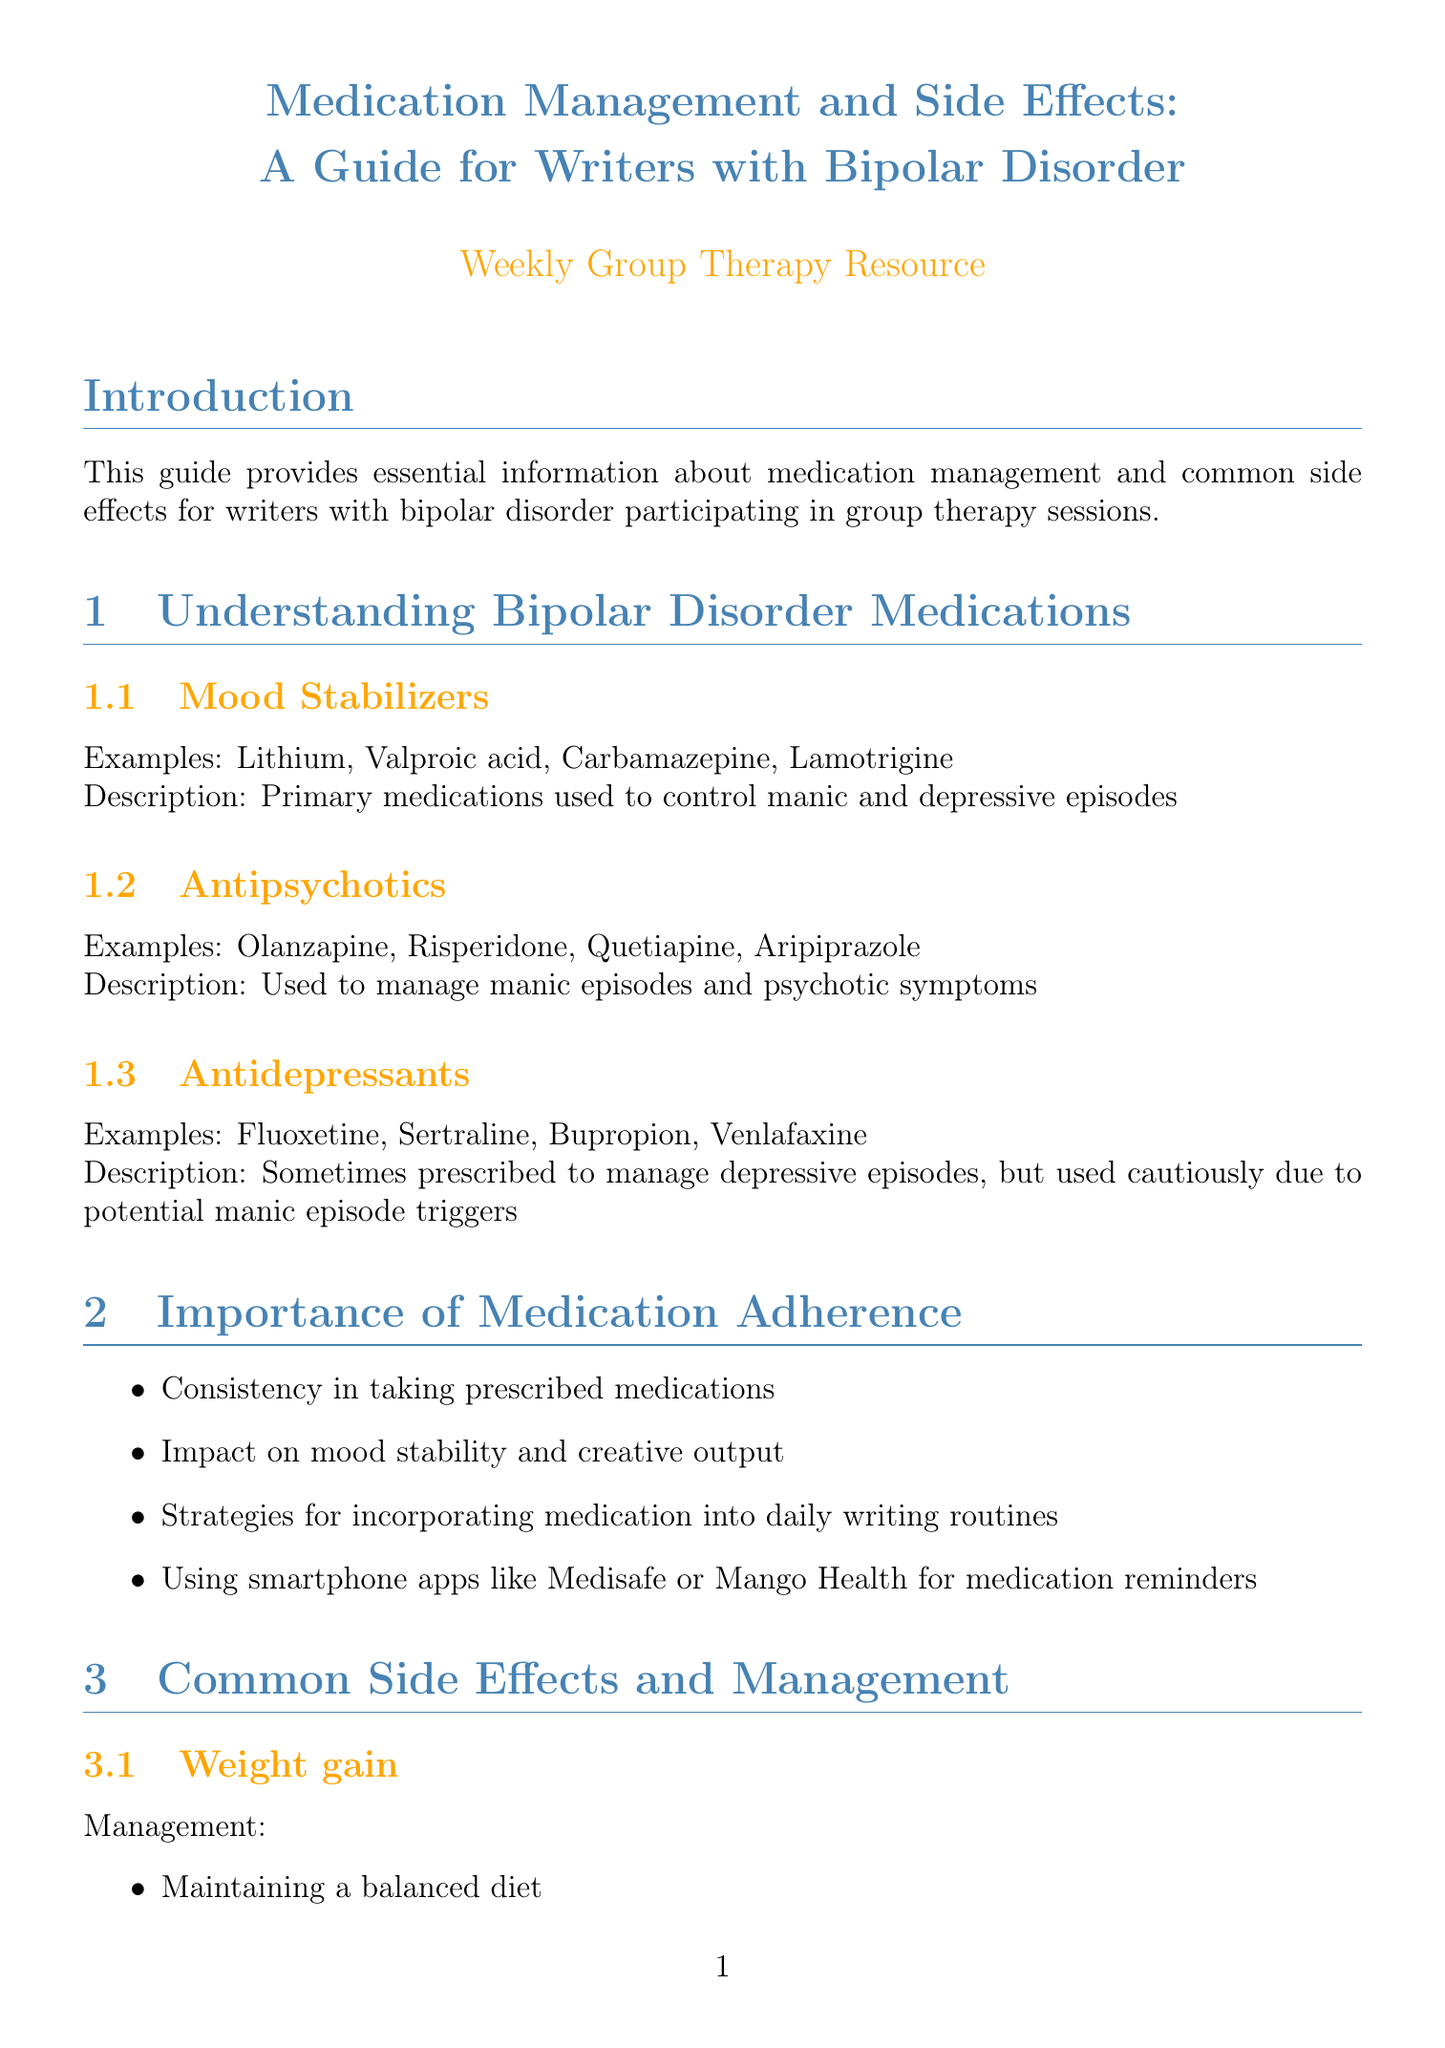What are the primary medications used to control manic and depressive episodes? The document lists mood stabilizers as the primary medications for controlling these episodes, with examples including Lithium and Valproic acid.
Answer: Mood stabilizers Which apps are suggested for medication reminders? The document mentions smartphone apps such as Medisafe and Mango Health for reminders about medication.
Answer: Medisafe, Mango Health What side effect is associated with cognitive fog? The document specifically mentions cognitive fog as a side effect that can occur with bipolar disorder medications.
Answer: Cognitive fog What is one strategy for managing weight gain as a side effect? The document provides several strategies, including maintaining a balanced diet as a method to manage this side effect.
Answer: Maintaining a balanced diet Name one resource for writers with bipolar disorder mentioned in the document. The document lists several resources, including the Depression and Bipolar Support Alliance (DBSA).
Answer: Depression and Bipolar Support Alliance (DBSA) What should you do to prepare for psychiatrist appointments? The document suggests preparing specific topics or questions to discuss during your appointments.
Answer: Preparing for psychiatrist appointments How does the document recommend monitoring mood and medication effectiveness? The document suggests keeping a mood journal as a method for monitoring mood and medication impact.
Answer: Keeping a mood journal What is a concern addressed regarding medication and creativity? The document discusses concerns that medication may dampen creativity for writers with bipolar disorder.
Answer: Medication dampening creativity 